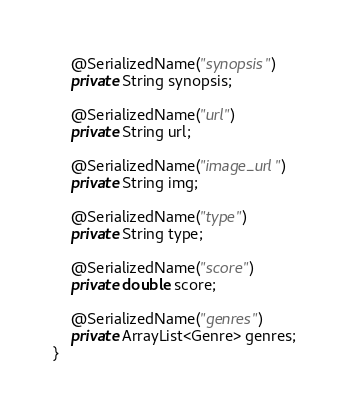Convert code to text. <code><loc_0><loc_0><loc_500><loc_500><_Java_>    @SerializedName("synopsis")
    private String synopsis;

    @SerializedName("url")
    private String url;

    @SerializedName("image_url")
    private String img;

    @SerializedName("type")
    private String type;

    @SerializedName("score")
    private double score;

    @SerializedName("genres")
    private ArrayList<Genre> genres;
}
</code> 